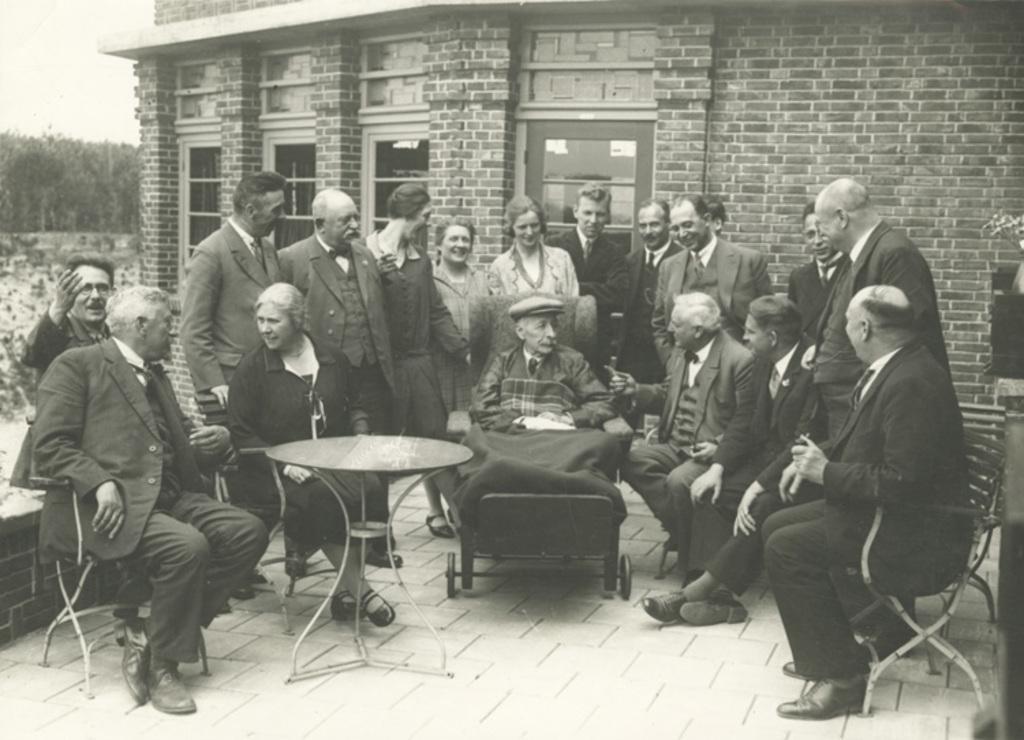In one or two sentences, can you explain what this image depicts? In this image there are group of people, few are standing and few are sitting. There is a building at the back side. At the left side there are trees, and at the top there is a sky. 